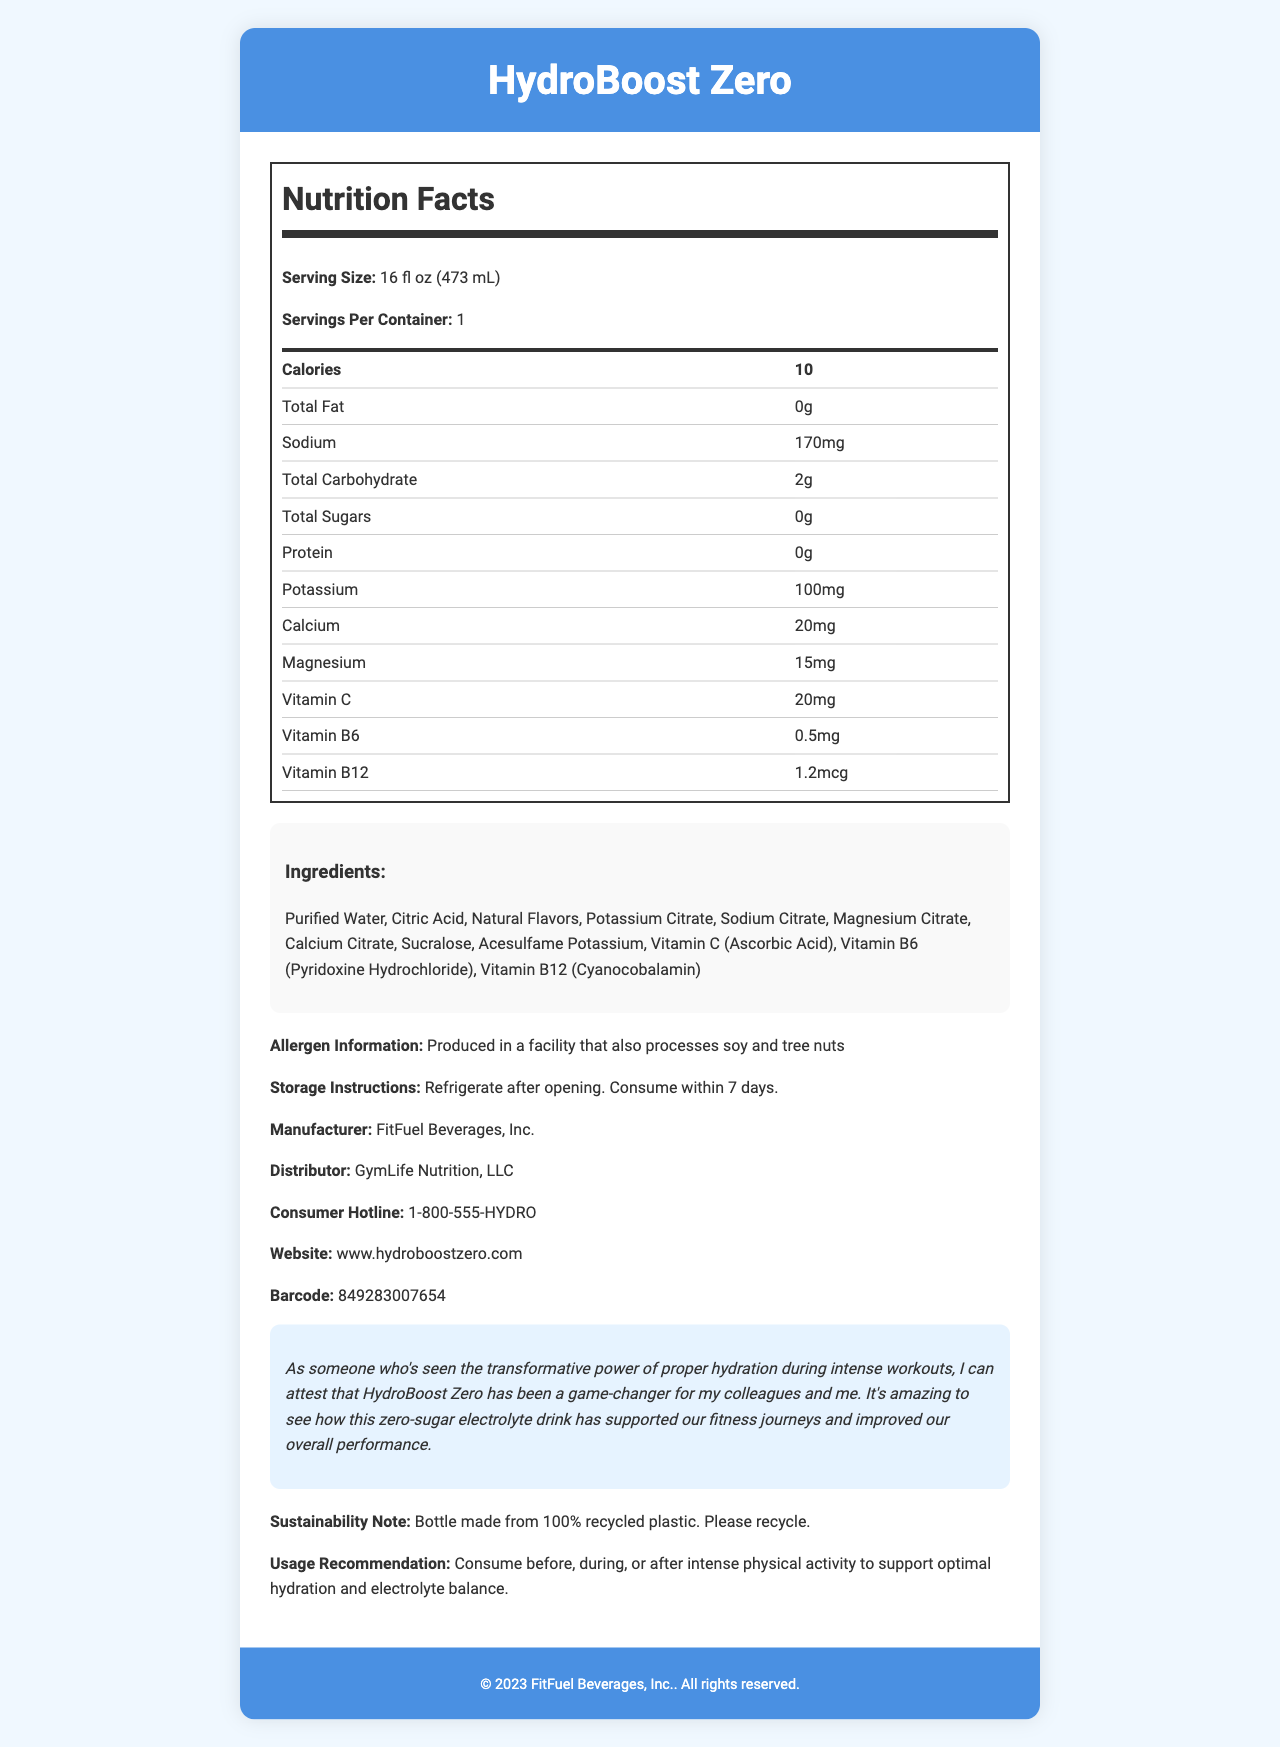what is the serving size for HydroBoost Zero? The document states that the serving size for HydroBoost Zero is 16 fl oz (473 mL).
Answer: 16 fl oz (473 mL) how many calories are in one serving of HydroBoost Zero? The document mentions that one serving contains 10 calories.
Answer: 10 what is the amount of sodium per serving? The document specifies that HydroBoost Zero has 170mg of sodium per serving.
Answer: 170mg which vitamins are included in HydroBoost Zero? The document lists Vitamin C, Vitamin B6, and Vitamin B12 in the nutrition facts.
Answer: Vitamin C, Vitamin B6, Vitamin B12 what are the storage instructions for HydroBoost Zero? The document states the storage instructions as refrigerate after opening and consume within 7 days.
Answer: Refrigerate after opening. Consume within 7 days. which ingredient in HydroBoost Zero is used as a sweetener? A. Sucrose B. Sucralose C. Stevia D. Aspartame The document lists Sucralose as one of the ingredients, which is a common sweetener.
Answer: B. Sucralose how much potassium does each serving of HydroBoost Zero contain? The document indicates that each serving contains 100mg of potassium.
Answer: 100mg what company manufactures HydroBoost Zero? The manufacturer of HydroBoost Zero, as listed in the document, is FitFuel Beverages, Inc.
Answer: FitFuel Beverages, Inc. where can consumers find more information about HydroBoost Zero? A. Pharmacy B. Retail Store C. www.hydroboostzero.com D. GymLife Nutrition, LLC The website listed for more information in the document is www.hydroboostzero.com.
Answer: C. www.hydroboostzero.com is HydroBoost Zero suitable for individuals with tree nut allergies? The document states it is produced in a facility that also processes soy and tree nuts, suggesting potential cross-contamination.
Answer: No what is the primary purpose of HydroBoost Zero according to the usage recommendation? The document recommends consuming it to support optimal hydration and electrolyte balance during intense physical activity.
Answer: To support optimal hydration and electrolyte balance during intense physical activity does HydroBoost Zero contain any protein? The document shows that the protein content of HydroBoost Zero is 0g.
Answer: No what sustainability practice is mentioned related to HydroBoost Zero? The document mentions that the bottle is made from 100% recycled plastic and encourages recycling.
Answer: Bottle made from 100% recycled plastic. Please recycle. summarize the main information provided in this document. The document provides comprehensive information about HydroBoost Zero, including its nutritional facts, ingredients, allergen info, storage instructions, manufacturer and distributor details, consumer hotline, and sustainability note. The main purpose of the drink is to support hydration and electrolyte balance for intense physical activities.
Answer: HydroBoost Zero is a low-calorie, zero-sugar electrolyte drink designed for hydration during intense workouts. It contains essential vitamins and minerals like Vitamin C, B6, B12, potassium, calcium, and magnesium. It has specific storage instructions and a sustainability note about using recycled plastic bottles. The drink is manufactured by FitFuel Beverages, Inc. and distributed by GymLife Nutrition, LLC, with additional information available on its website. where was HydroBoost Zero first launched? The document does not provide information about the launch location of HydroBoost Zero.
Answer: Cannot be determined 